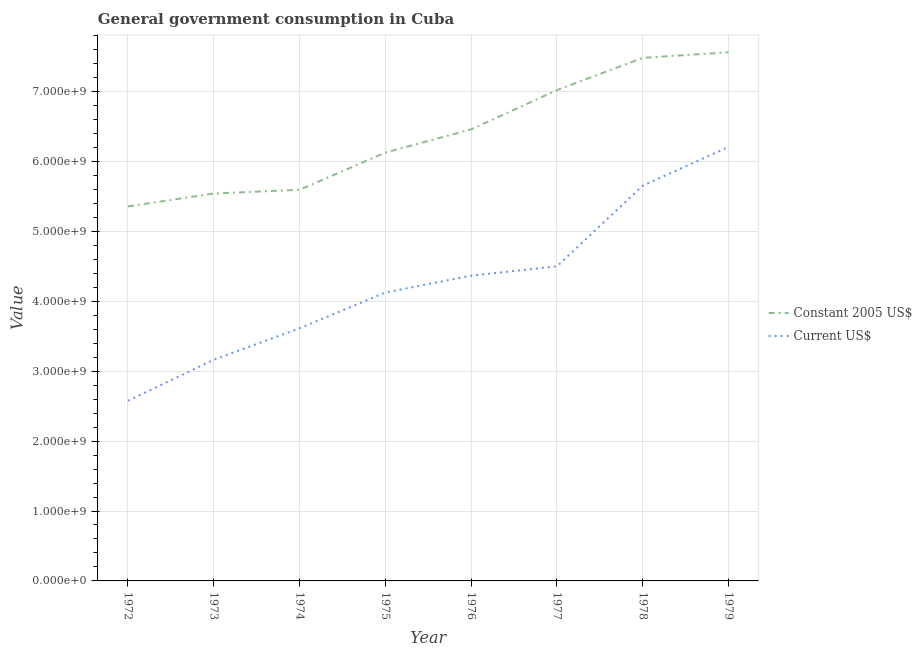What is the value consumed in constant 2005 us$ in 1975?
Offer a very short reply. 6.13e+09. Across all years, what is the maximum value consumed in current us$?
Offer a very short reply. 6.21e+09. Across all years, what is the minimum value consumed in constant 2005 us$?
Give a very brief answer. 5.36e+09. In which year was the value consumed in current us$ maximum?
Keep it short and to the point. 1979. What is the total value consumed in constant 2005 us$ in the graph?
Your answer should be very brief. 5.11e+1. What is the difference between the value consumed in current us$ in 1976 and that in 1979?
Offer a very short reply. -1.84e+09. What is the difference between the value consumed in current us$ in 1979 and the value consumed in constant 2005 us$ in 1972?
Provide a succinct answer. 8.50e+08. What is the average value consumed in constant 2005 us$ per year?
Your answer should be very brief. 6.39e+09. In the year 1972, what is the difference between the value consumed in current us$ and value consumed in constant 2005 us$?
Ensure brevity in your answer.  -2.78e+09. In how many years, is the value consumed in constant 2005 us$ greater than 4000000000?
Make the answer very short. 8. What is the ratio of the value consumed in constant 2005 us$ in 1978 to that in 1979?
Offer a very short reply. 0.99. Is the difference between the value consumed in current us$ in 1973 and 1979 greater than the difference between the value consumed in constant 2005 us$ in 1973 and 1979?
Provide a succinct answer. No. What is the difference between the highest and the second highest value consumed in constant 2005 us$?
Make the answer very short. 7.92e+07. What is the difference between the highest and the lowest value consumed in constant 2005 us$?
Ensure brevity in your answer.  2.20e+09. In how many years, is the value consumed in current us$ greater than the average value consumed in current us$ taken over all years?
Your answer should be compact. 4. Is the sum of the value consumed in current us$ in 1975 and 1978 greater than the maximum value consumed in constant 2005 us$ across all years?
Offer a terse response. Yes. Does the value consumed in constant 2005 us$ monotonically increase over the years?
Offer a very short reply. Yes. Is the value consumed in current us$ strictly greater than the value consumed in constant 2005 us$ over the years?
Provide a succinct answer. No. Is the value consumed in constant 2005 us$ strictly less than the value consumed in current us$ over the years?
Offer a terse response. No. How many years are there in the graph?
Offer a very short reply. 8. What is the difference between two consecutive major ticks on the Y-axis?
Provide a succinct answer. 1.00e+09. Does the graph contain any zero values?
Make the answer very short. No. Where does the legend appear in the graph?
Keep it short and to the point. Center right. What is the title of the graph?
Your answer should be compact. General government consumption in Cuba. Does "Methane" appear as one of the legend labels in the graph?
Ensure brevity in your answer.  No. What is the label or title of the X-axis?
Offer a terse response. Year. What is the label or title of the Y-axis?
Make the answer very short. Value. What is the Value in Constant 2005 US$ in 1972?
Your response must be concise. 5.36e+09. What is the Value of Current US$ in 1972?
Make the answer very short. 2.58e+09. What is the Value in Constant 2005 US$ in 1973?
Make the answer very short. 5.54e+09. What is the Value of Current US$ in 1973?
Make the answer very short. 3.16e+09. What is the Value of Constant 2005 US$ in 1974?
Ensure brevity in your answer.  5.59e+09. What is the Value of Current US$ in 1974?
Your response must be concise. 3.61e+09. What is the Value in Constant 2005 US$ in 1975?
Offer a very short reply. 6.13e+09. What is the Value in Current US$ in 1975?
Make the answer very short. 4.13e+09. What is the Value of Constant 2005 US$ in 1976?
Make the answer very short. 6.46e+09. What is the Value of Current US$ in 1976?
Your answer should be compact. 4.37e+09. What is the Value of Constant 2005 US$ in 1977?
Provide a succinct answer. 7.02e+09. What is the Value of Current US$ in 1977?
Provide a succinct answer. 4.50e+09. What is the Value in Constant 2005 US$ in 1978?
Provide a succinct answer. 7.48e+09. What is the Value of Current US$ in 1978?
Provide a short and direct response. 5.65e+09. What is the Value in Constant 2005 US$ in 1979?
Provide a succinct answer. 7.56e+09. What is the Value of Current US$ in 1979?
Your response must be concise. 6.21e+09. Across all years, what is the maximum Value in Constant 2005 US$?
Your answer should be very brief. 7.56e+09. Across all years, what is the maximum Value of Current US$?
Make the answer very short. 6.21e+09. Across all years, what is the minimum Value in Constant 2005 US$?
Offer a very short reply. 5.36e+09. Across all years, what is the minimum Value of Current US$?
Keep it short and to the point. 2.58e+09. What is the total Value of Constant 2005 US$ in the graph?
Offer a terse response. 5.11e+1. What is the total Value of Current US$ in the graph?
Offer a very short reply. 3.42e+1. What is the difference between the Value in Constant 2005 US$ in 1972 and that in 1973?
Ensure brevity in your answer.  -1.84e+08. What is the difference between the Value of Current US$ in 1972 and that in 1973?
Your answer should be compact. -5.87e+08. What is the difference between the Value in Constant 2005 US$ in 1972 and that in 1974?
Ensure brevity in your answer.  -2.38e+08. What is the difference between the Value of Current US$ in 1972 and that in 1974?
Give a very brief answer. -1.04e+09. What is the difference between the Value of Constant 2005 US$ in 1972 and that in 1975?
Your answer should be very brief. -7.70e+08. What is the difference between the Value in Current US$ in 1972 and that in 1975?
Your answer should be compact. -1.55e+09. What is the difference between the Value of Constant 2005 US$ in 1972 and that in 1976?
Offer a terse response. -1.10e+09. What is the difference between the Value in Current US$ in 1972 and that in 1976?
Your answer should be compact. -1.79e+09. What is the difference between the Value in Constant 2005 US$ in 1972 and that in 1977?
Ensure brevity in your answer.  -1.66e+09. What is the difference between the Value of Current US$ in 1972 and that in 1977?
Keep it short and to the point. -1.92e+09. What is the difference between the Value of Constant 2005 US$ in 1972 and that in 1978?
Provide a short and direct response. -2.12e+09. What is the difference between the Value of Current US$ in 1972 and that in 1978?
Your answer should be compact. -3.08e+09. What is the difference between the Value in Constant 2005 US$ in 1972 and that in 1979?
Provide a short and direct response. -2.20e+09. What is the difference between the Value of Current US$ in 1972 and that in 1979?
Make the answer very short. -3.63e+09. What is the difference between the Value in Constant 2005 US$ in 1973 and that in 1974?
Give a very brief answer. -5.41e+07. What is the difference between the Value of Current US$ in 1973 and that in 1974?
Offer a very short reply. -4.50e+08. What is the difference between the Value in Constant 2005 US$ in 1973 and that in 1975?
Offer a terse response. -5.86e+08. What is the difference between the Value in Current US$ in 1973 and that in 1975?
Offer a terse response. -9.62e+08. What is the difference between the Value in Constant 2005 US$ in 1973 and that in 1976?
Your answer should be very brief. -9.18e+08. What is the difference between the Value of Current US$ in 1973 and that in 1976?
Keep it short and to the point. -1.20e+09. What is the difference between the Value of Constant 2005 US$ in 1973 and that in 1977?
Your answer should be very brief. -1.48e+09. What is the difference between the Value of Current US$ in 1973 and that in 1977?
Provide a succinct answer. -1.34e+09. What is the difference between the Value in Constant 2005 US$ in 1973 and that in 1978?
Offer a very short reply. -1.94e+09. What is the difference between the Value of Current US$ in 1973 and that in 1978?
Offer a very short reply. -2.49e+09. What is the difference between the Value of Constant 2005 US$ in 1973 and that in 1979?
Keep it short and to the point. -2.02e+09. What is the difference between the Value of Current US$ in 1973 and that in 1979?
Give a very brief answer. -3.04e+09. What is the difference between the Value of Constant 2005 US$ in 1974 and that in 1975?
Offer a very short reply. -5.32e+08. What is the difference between the Value in Current US$ in 1974 and that in 1975?
Keep it short and to the point. -5.12e+08. What is the difference between the Value of Constant 2005 US$ in 1974 and that in 1976?
Make the answer very short. -8.64e+08. What is the difference between the Value in Current US$ in 1974 and that in 1976?
Keep it short and to the point. -7.53e+08. What is the difference between the Value of Constant 2005 US$ in 1974 and that in 1977?
Provide a succinct answer. -1.43e+09. What is the difference between the Value in Current US$ in 1974 and that in 1977?
Your answer should be compact. -8.87e+08. What is the difference between the Value in Constant 2005 US$ in 1974 and that in 1978?
Your response must be concise. -1.89e+09. What is the difference between the Value in Current US$ in 1974 and that in 1978?
Your response must be concise. -2.04e+09. What is the difference between the Value in Constant 2005 US$ in 1974 and that in 1979?
Give a very brief answer. -1.97e+09. What is the difference between the Value of Current US$ in 1974 and that in 1979?
Offer a very short reply. -2.59e+09. What is the difference between the Value in Constant 2005 US$ in 1975 and that in 1976?
Give a very brief answer. -3.33e+08. What is the difference between the Value in Current US$ in 1975 and that in 1976?
Give a very brief answer. -2.42e+08. What is the difference between the Value in Constant 2005 US$ in 1975 and that in 1977?
Provide a succinct answer. -8.94e+08. What is the difference between the Value in Current US$ in 1975 and that in 1977?
Your answer should be compact. -3.75e+08. What is the difference between the Value of Constant 2005 US$ in 1975 and that in 1978?
Provide a succinct answer. -1.36e+09. What is the difference between the Value of Current US$ in 1975 and that in 1978?
Your response must be concise. -1.53e+09. What is the difference between the Value in Constant 2005 US$ in 1975 and that in 1979?
Offer a very short reply. -1.43e+09. What is the difference between the Value in Current US$ in 1975 and that in 1979?
Provide a short and direct response. -2.08e+09. What is the difference between the Value in Constant 2005 US$ in 1976 and that in 1977?
Your response must be concise. -5.61e+08. What is the difference between the Value of Current US$ in 1976 and that in 1977?
Ensure brevity in your answer.  -1.33e+08. What is the difference between the Value of Constant 2005 US$ in 1976 and that in 1978?
Give a very brief answer. -1.02e+09. What is the difference between the Value in Current US$ in 1976 and that in 1978?
Your response must be concise. -1.29e+09. What is the difference between the Value in Constant 2005 US$ in 1976 and that in 1979?
Ensure brevity in your answer.  -1.10e+09. What is the difference between the Value of Current US$ in 1976 and that in 1979?
Your answer should be very brief. -1.84e+09. What is the difference between the Value of Constant 2005 US$ in 1977 and that in 1978?
Offer a very short reply. -4.62e+08. What is the difference between the Value of Current US$ in 1977 and that in 1978?
Offer a very short reply. -1.15e+09. What is the difference between the Value of Constant 2005 US$ in 1977 and that in 1979?
Offer a very short reply. -5.41e+08. What is the difference between the Value in Current US$ in 1977 and that in 1979?
Provide a short and direct response. -1.71e+09. What is the difference between the Value in Constant 2005 US$ in 1978 and that in 1979?
Make the answer very short. -7.92e+07. What is the difference between the Value of Current US$ in 1978 and that in 1979?
Your response must be concise. -5.53e+08. What is the difference between the Value of Constant 2005 US$ in 1972 and the Value of Current US$ in 1973?
Offer a very short reply. 2.19e+09. What is the difference between the Value of Constant 2005 US$ in 1972 and the Value of Current US$ in 1974?
Your answer should be very brief. 1.74e+09. What is the difference between the Value of Constant 2005 US$ in 1972 and the Value of Current US$ in 1975?
Give a very brief answer. 1.23e+09. What is the difference between the Value in Constant 2005 US$ in 1972 and the Value in Current US$ in 1976?
Ensure brevity in your answer.  9.90e+08. What is the difference between the Value of Constant 2005 US$ in 1972 and the Value of Current US$ in 1977?
Offer a terse response. 8.57e+08. What is the difference between the Value in Constant 2005 US$ in 1972 and the Value in Current US$ in 1978?
Make the answer very short. -2.97e+08. What is the difference between the Value of Constant 2005 US$ in 1972 and the Value of Current US$ in 1979?
Keep it short and to the point. -8.50e+08. What is the difference between the Value of Constant 2005 US$ in 1973 and the Value of Current US$ in 1974?
Your answer should be very brief. 1.93e+09. What is the difference between the Value in Constant 2005 US$ in 1973 and the Value in Current US$ in 1975?
Offer a very short reply. 1.42e+09. What is the difference between the Value in Constant 2005 US$ in 1973 and the Value in Current US$ in 1976?
Give a very brief answer. 1.17e+09. What is the difference between the Value of Constant 2005 US$ in 1973 and the Value of Current US$ in 1977?
Offer a very short reply. 1.04e+09. What is the difference between the Value of Constant 2005 US$ in 1973 and the Value of Current US$ in 1978?
Provide a short and direct response. -1.14e+08. What is the difference between the Value of Constant 2005 US$ in 1973 and the Value of Current US$ in 1979?
Make the answer very short. -6.66e+08. What is the difference between the Value in Constant 2005 US$ in 1974 and the Value in Current US$ in 1975?
Make the answer very short. 1.47e+09. What is the difference between the Value of Constant 2005 US$ in 1974 and the Value of Current US$ in 1976?
Provide a succinct answer. 1.23e+09. What is the difference between the Value in Constant 2005 US$ in 1974 and the Value in Current US$ in 1977?
Make the answer very short. 1.09e+09. What is the difference between the Value of Constant 2005 US$ in 1974 and the Value of Current US$ in 1978?
Provide a short and direct response. -5.95e+07. What is the difference between the Value in Constant 2005 US$ in 1974 and the Value in Current US$ in 1979?
Your answer should be compact. -6.12e+08. What is the difference between the Value of Constant 2005 US$ in 1975 and the Value of Current US$ in 1976?
Your answer should be compact. 1.76e+09. What is the difference between the Value in Constant 2005 US$ in 1975 and the Value in Current US$ in 1977?
Make the answer very short. 1.63e+09. What is the difference between the Value in Constant 2005 US$ in 1975 and the Value in Current US$ in 1978?
Provide a succinct answer. 4.72e+08. What is the difference between the Value of Constant 2005 US$ in 1975 and the Value of Current US$ in 1979?
Make the answer very short. -8.07e+07. What is the difference between the Value of Constant 2005 US$ in 1976 and the Value of Current US$ in 1977?
Your response must be concise. 1.96e+09. What is the difference between the Value in Constant 2005 US$ in 1976 and the Value in Current US$ in 1978?
Provide a short and direct response. 8.05e+08. What is the difference between the Value of Constant 2005 US$ in 1976 and the Value of Current US$ in 1979?
Give a very brief answer. 2.52e+08. What is the difference between the Value in Constant 2005 US$ in 1977 and the Value in Current US$ in 1978?
Provide a short and direct response. 1.37e+09. What is the difference between the Value in Constant 2005 US$ in 1977 and the Value in Current US$ in 1979?
Your answer should be very brief. 8.13e+08. What is the difference between the Value of Constant 2005 US$ in 1978 and the Value of Current US$ in 1979?
Your response must be concise. 1.27e+09. What is the average Value in Constant 2005 US$ per year?
Your answer should be compact. 6.39e+09. What is the average Value in Current US$ per year?
Your answer should be compact. 4.28e+09. In the year 1972, what is the difference between the Value in Constant 2005 US$ and Value in Current US$?
Your answer should be very brief. 2.78e+09. In the year 1973, what is the difference between the Value of Constant 2005 US$ and Value of Current US$?
Ensure brevity in your answer.  2.38e+09. In the year 1974, what is the difference between the Value in Constant 2005 US$ and Value in Current US$?
Offer a very short reply. 1.98e+09. In the year 1975, what is the difference between the Value in Constant 2005 US$ and Value in Current US$?
Your answer should be compact. 2.00e+09. In the year 1976, what is the difference between the Value in Constant 2005 US$ and Value in Current US$?
Ensure brevity in your answer.  2.09e+09. In the year 1977, what is the difference between the Value of Constant 2005 US$ and Value of Current US$?
Provide a short and direct response. 2.52e+09. In the year 1978, what is the difference between the Value in Constant 2005 US$ and Value in Current US$?
Your answer should be compact. 1.83e+09. In the year 1979, what is the difference between the Value of Constant 2005 US$ and Value of Current US$?
Your answer should be compact. 1.35e+09. What is the ratio of the Value of Constant 2005 US$ in 1972 to that in 1973?
Your answer should be compact. 0.97. What is the ratio of the Value of Current US$ in 1972 to that in 1973?
Provide a succinct answer. 0.81. What is the ratio of the Value of Constant 2005 US$ in 1972 to that in 1974?
Your answer should be compact. 0.96. What is the ratio of the Value of Current US$ in 1972 to that in 1974?
Give a very brief answer. 0.71. What is the ratio of the Value in Constant 2005 US$ in 1972 to that in 1975?
Make the answer very short. 0.87. What is the ratio of the Value of Current US$ in 1972 to that in 1975?
Offer a very short reply. 0.62. What is the ratio of the Value of Constant 2005 US$ in 1972 to that in 1976?
Provide a succinct answer. 0.83. What is the ratio of the Value of Current US$ in 1972 to that in 1976?
Your answer should be compact. 0.59. What is the ratio of the Value in Constant 2005 US$ in 1972 to that in 1977?
Provide a short and direct response. 0.76. What is the ratio of the Value of Current US$ in 1972 to that in 1977?
Offer a terse response. 0.57. What is the ratio of the Value in Constant 2005 US$ in 1972 to that in 1978?
Give a very brief answer. 0.72. What is the ratio of the Value of Current US$ in 1972 to that in 1978?
Ensure brevity in your answer.  0.46. What is the ratio of the Value in Constant 2005 US$ in 1972 to that in 1979?
Make the answer very short. 0.71. What is the ratio of the Value in Current US$ in 1972 to that in 1979?
Provide a short and direct response. 0.42. What is the ratio of the Value in Constant 2005 US$ in 1973 to that in 1974?
Give a very brief answer. 0.99. What is the ratio of the Value of Current US$ in 1973 to that in 1974?
Provide a short and direct response. 0.88. What is the ratio of the Value of Constant 2005 US$ in 1973 to that in 1975?
Provide a short and direct response. 0.9. What is the ratio of the Value of Current US$ in 1973 to that in 1975?
Your response must be concise. 0.77. What is the ratio of the Value in Constant 2005 US$ in 1973 to that in 1976?
Your response must be concise. 0.86. What is the ratio of the Value of Current US$ in 1973 to that in 1976?
Provide a succinct answer. 0.72. What is the ratio of the Value in Constant 2005 US$ in 1973 to that in 1977?
Keep it short and to the point. 0.79. What is the ratio of the Value of Current US$ in 1973 to that in 1977?
Keep it short and to the point. 0.7. What is the ratio of the Value of Constant 2005 US$ in 1973 to that in 1978?
Provide a succinct answer. 0.74. What is the ratio of the Value in Current US$ in 1973 to that in 1978?
Make the answer very short. 0.56. What is the ratio of the Value of Constant 2005 US$ in 1973 to that in 1979?
Your answer should be compact. 0.73. What is the ratio of the Value in Current US$ in 1973 to that in 1979?
Make the answer very short. 0.51. What is the ratio of the Value in Constant 2005 US$ in 1974 to that in 1975?
Offer a very short reply. 0.91. What is the ratio of the Value in Current US$ in 1974 to that in 1975?
Provide a short and direct response. 0.88. What is the ratio of the Value of Constant 2005 US$ in 1974 to that in 1976?
Offer a terse response. 0.87. What is the ratio of the Value of Current US$ in 1974 to that in 1976?
Offer a terse response. 0.83. What is the ratio of the Value of Constant 2005 US$ in 1974 to that in 1977?
Give a very brief answer. 0.8. What is the ratio of the Value in Current US$ in 1974 to that in 1977?
Make the answer very short. 0.8. What is the ratio of the Value of Constant 2005 US$ in 1974 to that in 1978?
Ensure brevity in your answer.  0.75. What is the ratio of the Value of Current US$ in 1974 to that in 1978?
Provide a succinct answer. 0.64. What is the ratio of the Value in Constant 2005 US$ in 1974 to that in 1979?
Ensure brevity in your answer.  0.74. What is the ratio of the Value of Current US$ in 1974 to that in 1979?
Give a very brief answer. 0.58. What is the ratio of the Value of Constant 2005 US$ in 1975 to that in 1976?
Provide a succinct answer. 0.95. What is the ratio of the Value of Current US$ in 1975 to that in 1976?
Offer a terse response. 0.94. What is the ratio of the Value of Constant 2005 US$ in 1975 to that in 1977?
Provide a succinct answer. 0.87. What is the ratio of the Value of Constant 2005 US$ in 1975 to that in 1978?
Provide a short and direct response. 0.82. What is the ratio of the Value in Current US$ in 1975 to that in 1978?
Your response must be concise. 0.73. What is the ratio of the Value in Constant 2005 US$ in 1975 to that in 1979?
Offer a terse response. 0.81. What is the ratio of the Value in Current US$ in 1975 to that in 1979?
Keep it short and to the point. 0.66. What is the ratio of the Value of Constant 2005 US$ in 1976 to that in 1977?
Keep it short and to the point. 0.92. What is the ratio of the Value in Current US$ in 1976 to that in 1977?
Keep it short and to the point. 0.97. What is the ratio of the Value in Constant 2005 US$ in 1976 to that in 1978?
Provide a succinct answer. 0.86. What is the ratio of the Value in Current US$ in 1976 to that in 1978?
Keep it short and to the point. 0.77. What is the ratio of the Value in Constant 2005 US$ in 1976 to that in 1979?
Provide a short and direct response. 0.85. What is the ratio of the Value in Current US$ in 1976 to that in 1979?
Your response must be concise. 0.7. What is the ratio of the Value in Constant 2005 US$ in 1977 to that in 1978?
Provide a short and direct response. 0.94. What is the ratio of the Value of Current US$ in 1977 to that in 1978?
Provide a succinct answer. 0.8. What is the ratio of the Value of Constant 2005 US$ in 1977 to that in 1979?
Make the answer very short. 0.93. What is the ratio of the Value of Current US$ in 1977 to that in 1979?
Your response must be concise. 0.72. What is the ratio of the Value of Current US$ in 1978 to that in 1979?
Give a very brief answer. 0.91. What is the difference between the highest and the second highest Value of Constant 2005 US$?
Your answer should be compact. 7.92e+07. What is the difference between the highest and the second highest Value of Current US$?
Provide a succinct answer. 5.53e+08. What is the difference between the highest and the lowest Value in Constant 2005 US$?
Keep it short and to the point. 2.20e+09. What is the difference between the highest and the lowest Value in Current US$?
Your response must be concise. 3.63e+09. 